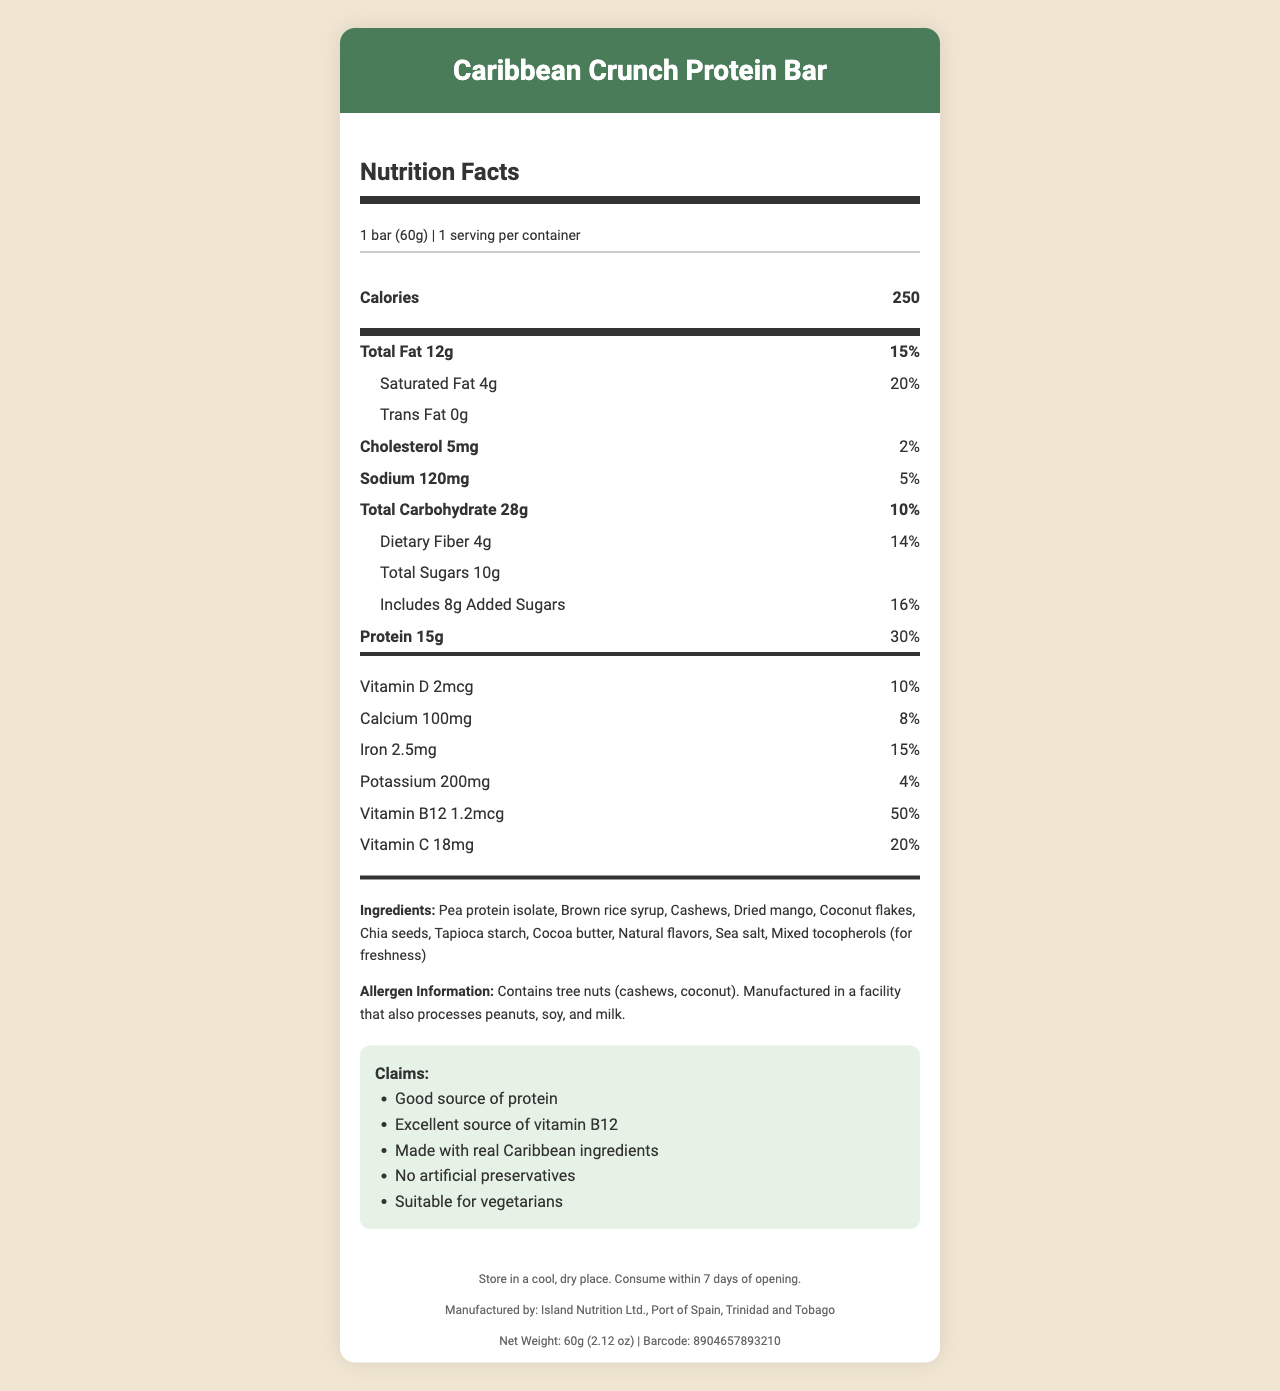what is the total fat content per serving? The document lists the total fat content for one serving as 12g.
Answer: 12g what is the calorie count per serving? The document specifies that each serving of the product contains 250 calories.
Answer: 250 how much protein is in one serving? The document indicates that one serving contains 15g of protein.
Answer: 15g what is the serving size of the Caribbean Crunch Protein Bar? The document states the serving size as "1 bar (60g)".
Answer: 1 bar (60g) name two ingredients in the Caribbean Crunch Protein Bar The listed ingredients include pea protein isolate and brown rice syrup among others.
Answer: Pea protein isolate, Brown rice syrup what is the percentage of daily value for iron in one serving? The document states that the daily value percentage for iron is 15%.
Answer: 15% which vitamin has the highest percentage of daily value in one serving? A. Vitamin D B. Calcium C. Vitamin B12 The document states that Vitamin B12 has the highest daily value percentage at 50%.
Answer: C. Vitamin B12 how much-added sugars are included in one serving? A. 6g B. 8g C. 10g The document specifies that there are 8g of added sugars in one serving.
Answer: B. 8g are there any tree nuts in the Caribbean Crunch Protein Bar? The document clearly states that it contains tree nuts, specifically cashews and coconut.
Answer: Yes is this product suitable for vegetarians? The claim statements include "Suitable for vegetarians".
Answer: Yes summarize the key nutritional information of the Caribbean Crunch Protein Bar The answer summarizes the main points of calories, macronutrients, vitamins, ingredients, and dietary claims found in the document.
Answer: The Caribbean Crunch Protein Bar contains 250 calories per serving, with 12g total fat, 15g protein, and 28g total carbohydrates. It contains key vitamins including a high daily value of Vitamin B12 (50%) and Vitamin C (20%). It’s designed with natural Caribbean ingredients, suitable for vegetarians, and contains tree nuts. what is the total dietary fiber content? The document lists the total dietary fiber content as 4g.
Answer: 4g what is the cholesterol content in one serving? The document states that the cholesterol content per serving is 5mg.
Answer: 5mg what are the storage instructions for the product? The document provides detailed storage instructions, recommending a cool, dry place and consumption within 7 days of opening.
Answer: Store in a cool, dry place. Consume within 7 days of opening. who is the manufacturer of the product? The document lists the manufacturer as Island Nutrition Ltd., located in Port of Spain.
Answer: Island Nutrition Ltd., Port of Spain, Trinidad and Tobago does the product contain peanuts? The document mentions that it is manufactured in a facility that processes peanuts, but does not confirm if the product itself contains peanuts.
Answer: Cannot be determined what is the product's net weight? The document specifies the net weight of the product as 60g (2.12 oz).
Answer: 60g (2.12 oz) which vitamin is present at a quantity of 18mg in the product? The document states that Vitamin C is present at 18mg per serving.
Answer: Vitamin C 